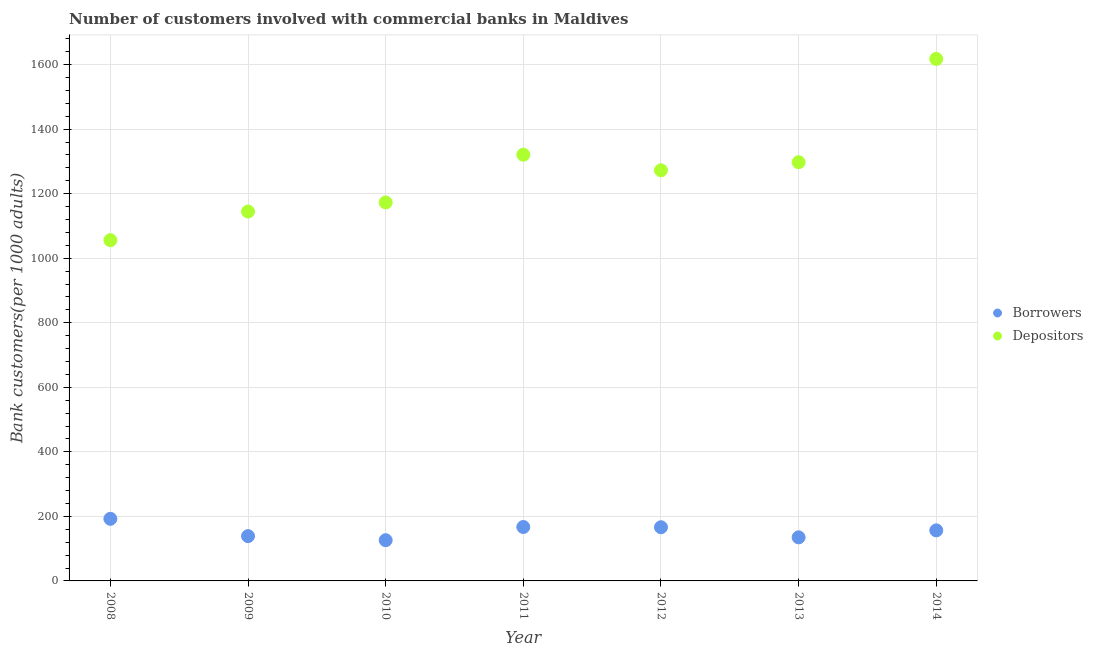How many different coloured dotlines are there?
Your answer should be very brief. 2. Is the number of dotlines equal to the number of legend labels?
Offer a terse response. Yes. What is the number of depositors in 2014?
Your answer should be compact. 1617.4. Across all years, what is the maximum number of depositors?
Give a very brief answer. 1617.4. Across all years, what is the minimum number of depositors?
Make the answer very short. 1055.84. In which year was the number of borrowers maximum?
Keep it short and to the point. 2008. In which year was the number of depositors minimum?
Offer a terse response. 2008. What is the total number of borrowers in the graph?
Offer a terse response. 1082.34. What is the difference between the number of borrowers in 2011 and that in 2013?
Ensure brevity in your answer.  32.03. What is the difference between the number of borrowers in 2011 and the number of depositors in 2012?
Give a very brief answer. -1105.32. What is the average number of borrowers per year?
Your answer should be very brief. 154.62. In the year 2014, what is the difference between the number of depositors and number of borrowers?
Provide a succinct answer. 1460.79. In how many years, is the number of depositors greater than 1400?
Make the answer very short. 1. What is the ratio of the number of depositors in 2012 to that in 2014?
Provide a short and direct response. 0.79. Is the number of depositors in 2011 less than that in 2014?
Make the answer very short. Yes. Is the difference between the number of depositors in 2009 and 2014 greater than the difference between the number of borrowers in 2009 and 2014?
Your answer should be compact. No. What is the difference between the highest and the second highest number of depositors?
Keep it short and to the point. 296.71. What is the difference between the highest and the lowest number of depositors?
Your answer should be compact. 561.56. In how many years, is the number of depositors greater than the average number of depositors taken over all years?
Offer a terse response. 4. How many dotlines are there?
Your response must be concise. 2. How many legend labels are there?
Give a very brief answer. 2. What is the title of the graph?
Your answer should be compact. Number of customers involved with commercial banks in Maldives. Does "IMF concessional" appear as one of the legend labels in the graph?
Make the answer very short. No. What is the label or title of the X-axis?
Offer a very short reply. Year. What is the label or title of the Y-axis?
Offer a very short reply. Bank customers(per 1000 adults). What is the Bank customers(per 1000 adults) of Borrowers in 2008?
Keep it short and to the point. 192.42. What is the Bank customers(per 1000 adults) of Depositors in 2008?
Provide a short and direct response. 1055.84. What is the Bank customers(per 1000 adults) in Borrowers in 2009?
Offer a very short reply. 138.77. What is the Bank customers(per 1000 adults) in Depositors in 2009?
Give a very brief answer. 1144.57. What is the Bank customers(per 1000 adults) of Borrowers in 2010?
Provide a succinct answer. 126.14. What is the Bank customers(per 1000 adults) in Depositors in 2010?
Offer a terse response. 1172.79. What is the Bank customers(per 1000 adults) in Borrowers in 2011?
Your answer should be very brief. 167.07. What is the Bank customers(per 1000 adults) in Depositors in 2011?
Offer a very short reply. 1320.69. What is the Bank customers(per 1000 adults) of Borrowers in 2012?
Offer a very short reply. 166.29. What is the Bank customers(per 1000 adults) of Depositors in 2012?
Offer a terse response. 1272.39. What is the Bank customers(per 1000 adults) in Borrowers in 2013?
Provide a short and direct response. 135.04. What is the Bank customers(per 1000 adults) of Depositors in 2013?
Keep it short and to the point. 1297.48. What is the Bank customers(per 1000 adults) in Borrowers in 2014?
Your response must be concise. 156.61. What is the Bank customers(per 1000 adults) of Depositors in 2014?
Make the answer very short. 1617.4. Across all years, what is the maximum Bank customers(per 1000 adults) of Borrowers?
Your response must be concise. 192.42. Across all years, what is the maximum Bank customers(per 1000 adults) of Depositors?
Give a very brief answer. 1617.4. Across all years, what is the minimum Bank customers(per 1000 adults) in Borrowers?
Ensure brevity in your answer.  126.14. Across all years, what is the minimum Bank customers(per 1000 adults) in Depositors?
Offer a terse response. 1055.84. What is the total Bank customers(per 1000 adults) of Borrowers in the graph?
Give a very brief answer. 1082.34. What is the total Bank customers(per 1000 adults) of Depositors in the graph?
Give a very brief answer. 8881.16. What is the difference between the Bank customers(per 1000 adults) of Borrowers in 2008 and that in 2009?
Offer a very short reply. 53.66. What is the difference between the Bank customers(per 1000 adults) in Depositors in 2008 and that in 2009?
Ensure brevity in your answer.  -88.73. What is the difference between the Bank customers(per 1000 adults) of Borrowers in 2008 and that in 2010?
Ensure brevity in your answer.  66.29. What is the difference between the Bank customers(per 1000 adults) in Depositors in 2008 and that in 2010?
Offer a terse response. -116.95. What is the difference between the Bank customers(per 1000 adults) in Borrowers in 2008 and that in 2011?
Your answer should be very brief. 25.36. What is the difference between the Bank customers(per 1000 adults) in Depositors in 2008 and that in 2011?
Ensure brevity in your answer.  -264.85. What is the difference between the Bank customers(per 1000 adults) in Borrowers in 2008 and that in 2012?
Offer a terse response. 26.13. What is the difference between the Bank customers(per 1000 adults) of Depositors in 2008 and that in 2012?
Give a very brief answer. -216.55. What is the difference between the Bank customers(per 1000 adults) of Borrowers in 2008 and that in 2013?
Your response must be concise. 57.38. What is the difference between the Bank customers(per 1000 adults) of Depositors in 2008 and that in 2013?
Ensure brevity in your answer.  -241.64. What is the difference between the Bank customers(per 1000 adults) in Borrowers in 2008 and that in 2014?
Your answer should be compact. 35.81. What is the difference between the Bank customers(per 1000 adults) of Depositors in 2008 and that in 2014?
Your response must be concise. -561.56. What is the difference between the Bank customers(per 1000 adults) of Borrowers in 2009 and that in 2010?
Ensure brevity in your answer.  12.63. What is the difference between the Bank customers(per 1000 adults) in Depositors in 2009 and that in 2010?
Your answer should be compact. -28.22. What is the difference between the Bank customers(per 1000 adults) in Borrowers in 2009 and that in 2011?
Provide a short and direct response. -28.3. What is the difference between the Bank customers(per 1000 adults) of Depositors in 2009 and that in 2011?
Offer a very short reply. -176.13. What is the difference between the Bank customers(per 1000 adults) in Borrowers in 2009 and that in 2012?
Provide a succinct answer. -27.52. What is the difference between the Bank customers(per 1000 adults) in Depositors in 2009 and that in 2012?
Give a very brief answer. -127.82. What is the difference between the Bank customers(per 1000 adults) in Borrowers in 2009 and that in 2013?
Provide a succinct answer. 3.73. What is the difference between the Bank customers(per 1000 adults) in Depositors in 2009 and that in 2013?
Your answer should be compact. -152.92. What is the difference between the Bank customers(per 1000 adults) of Borrowers in 2009 and that in 2014?
Your answer should be very brief. -17.85. What is the difference between the Bank customers(per 1000 adults) in Depositors in 2009 and that in 2014?
Provide a short and direct response. -472.84. What is the difference between the Bank customers(per 1000 adults) in Borrowers in 2010 and that in 2011?
Give a very brief answer. -40.93. What is the difference between the Bank customers(per 1000 adults) of Depositors in 2010 and that in 2011?
Your answer should be very brief. -147.91. What is the difference between the Bank customers(per 1000 adults) of Borrowers in 2010 and that in 2012?
Provide a succinct answer. -40.15. What is the difference between the Bank customers(per 1000 adults) of Depositors in 2010 and that in 2012?
Ensure brevity in your answer.  -99.6. What is the difference between the Bank customers(per 1000 adults) in Borrowers in 2010 and that in 2013?
Your answer should be compact. -8.9. What is the difference between the Bank customers(per 1000 adults) in Depositors in 2010 and that in 2013?
Provide a succinct answer. -124.7. What is the difference between the Bank customers(per 1000 adults) in Borrowers in 2010 and that in 2014?
Keep it short and to the point. -30.48. What is the difference between the Bank customers(per 1000 adults) of Depositors in 2010 and that in 2014?
Provide a short and direct response. -444.62. What is the difference between the Bank customers(per 1000 adults) in Borrowers in 2011 and that in 2012?
Your answer should be very brief. 0.78. What is the difference between the Bank customers(per 1000 adults) in Depositors in 2011 and that in 2012?
Provide a short and direct response. 48.3. What is the difference between the Bank customers(per 1000 adults) in Borrowers in 2011 and that in 2013?
Offer a terse response. 32.03. What is the difference between the Bank customers(per 1000 adults) in Depositors in 2011 and that in 2013?
Offer a terse response. 23.21. What is the difference between the Bank customers(per 1000 adults) of Borrowers in 2011 and that in 2014?
Make the answer very short. 10.45. What is the difference between the Bank customers(per 1000 adults) of Depositors in 2011 and that in 2014?
Your answer should be compact. -296.71. What is the difference between the Bank customers(per 1000 adults) in Borrowers in 2012 and that in 2013?
Provide a short and direct response. 31.25. What is the difference between the Bank customers(per 1000 adults) of Depositors in 2012 and that in 2013?
Ensure brevity in your answer.  -25.1. What is the difference between the Bank customers(per 1000 adults) of Borrowers in 2012 and that in 2014?
Your answer should be compact. 9.68. What is the difference between the Bank customers(per 1000 adults) of Depositors in 2012 and that in 2014?
Your answer should be very brief. -345.02. What is the difference between the Bank customers(per 1000 adults) in Borrowers in 2013 and that in 2014?
Your answer should be compact. -21.58. What is the difference between the Bank customers(per 1000 adults) of Depositors in 2013 and that in 2014?
Your answer should be compact. -319.92. What is the difference between the Bank customers(per 1000 adults) in Borrowers in 2008 and the Bank customers(per 1000 adults) in Depositors in 2009?
Keep it short and to the point. -952.14. What is the difference between the Bank customers(per 1000 adults) of Borrowers in 2008 and the Bank customers(per 1000 adults) of Depositors in 2010?
Your response must be concise. -980.36. What is the difference between the Bank customers(per 1000 adults) in Borrowers in 2008 and the Bank customers(per 1000 adults) in Depositors in 2011?
Your answer should be very brief. -1128.27. What is the difference between the Bank customers(per 1000 adults) of Borrowers in 2008 and the Bank customers(per 1000 adults) of Depositors in 2012?
Offer a very short reply. -1079.96. What is the difference between the Bank customers(per 1000 adults) of Borrowers in 2008 and the Bank customers(per 1000 adults) of Depositors in 2013?
Make the answer very short. -1105.06. What is the difference between the Bank customers(per 1000 adults) in Borrowers in 2008 and the Bank customers(per 1000 adults) in Depositors in 2014?
Keep it short and to the point. -1424.98. What is the difference between the Bank customers(per 1000 adults) in Borrowers in 2009 and the Bank customers(per 1000 adults) in Depositors in 2010?
Your answer should be compact. -1034.02. What is the difference between the Bank customers(per 1000 adults) of Borrowers in 2009 and the Bank customers(per 1000 adults) of Depositors in 2011?
Your response must be concise. -1181.92. What is the difference between the Bank customers(per 1000 adults) in Borrowers in 2009 and the Bank customers(per 1000 adults) in Depositors in 2012?
Provide a short and direct response. -1133.62. What is the difference between the Bank customers(per 1000 adults) in Borrowers in 2009 and the Bank customers(per 1000 adults) in Depositors in 2013?
Offer a very short reply. -1158.72. What is the difference between the Bank customers(per 1000 adults) of Borrowers in 2009 and the Bank customers(per 1000 adults) of Depositors in 2014?
Your answer should be very brief. -1478.64. What is the difference between the Bank customers(per 1000 adults) in Borrowers in 2010 and the Bank customers(per 1000 adults) in Depositors in 2011?
Your answer should be compact. -1194.55. What is the difference between the Bank customers(per 1000 adults) of Borrowers in 2010 and the Bank customers(per 1000 adults) of Depositors in 2012?
Provide a short and direct response. -1146.25. What is the difference between the Bank customers(per 1000 adults) of Borrowers in 2010 and the Bank customers(per 1000 adults) of Depositors in 2013?
Offer a very short reply. -1171.35. What is the difference between the Bank customers(per 1000 adults) in Borrowers in 2010 and the Bank customers(per 1000 adults) in Depositors in 2014?
Your answer should be compact. -1491.27. What is the difference between the Bank customers(per 1000 adults) in Borrowers in 2011 and the Bank customers(per 1000 adults) in Depositors in 2012?
Give a very brief answer. -1105.32. What is the difference between the Bank customers(per 1000 adults) of Borrowers in 2011 and the Bank customers(per 1000 adults) of Depositors in 2013?
Give a very brief answer. -1130.42. What is the difference between the Bank customers(per 1000 adults) of Borrowers in 2011 and the Bank customers(per 1000 adults) of Depositors in 2014?
Provide a short and direct response. -1450.34. What is the difference between the Bank customers(per 1000 adults) of Borrowers in 2012 and the Bank customers(per 1000 adults) of Depositors in 2013?
Your answer should be compact. -1131.19. What is the difference between the Bank customers(per 1000 adults) in Borrowers in 2012 and the Bank customers(per 1000 adults) in Depositors in 2014?
Ensure brevity in your answer.  -1451.11. What is the difference between the Bank customers(per 1000 adults) in Borrowers in 2013 and the Bank customers(per 1000 adults) in Depositors in 2014?
Give a very brief answer. -1482.37. What is the average Bank customers(per 1000 adults) of Borrowers per year?
Provide a short and direct response. 154.62. What is the average Bank customers(per 1000 adults) in Depositors per year?
Your answer should be very brief. 1268.74. In the year 2008, what is the difference between the Bank customers(per 1000 adults) in Borrowers and Bank customers(per 1000 adults) in Depositors?
Offer a very short reply. -863.42. In the year 2009, what is the difference between the Bank customers(per 1000 adults) of Borrowers and Bank customers(per 1000 adults) of Depositors?
Make the answer very short. -1005.8. In the year 2010, what is the difference between the Bank customers(per 1000 adults) of Borrowers and Bank customers(per 1000 adults) of Depositors?
Your answer should be very brief. -1046.65. In the year 2011, what is the difference between the Bank customers(per 1000 adults) of Borrowers and Bank customers(per 1000 adults) of Depositors?
Make the answer very short. -1153.63. In the year 2012, what is the difference between the Bank customers(per 1000 adults) of Borrowers and Bank customers(per 1000 adults) of Depositors?
Your answer should be very brief. -1106.1. In the year 2013, what is the difference between the Bank customers(per 1000 adults) in Borrowers and Bank customers(per 1000 adults) in Depositors?
Offer a terse response. -1162.45. In the year 2014, what is the difference between the Bank customers(per 1000 adults) in Borrowers and Bank customers(per 1000 adults) in Depositors?
Your answer should be very brief. -1460.79. What is the ratio of the Bank customers(per 1000 adults) of Borrowers in 2008 to that in 2009?
Keep it short and to the point. 1.39. What is the ratio of the Bank customers(per 1000 adults) in Depositors in 2008 to that in 2009?
Make the answer very short. 0.92. What is the ratio of the Bank customers(per 1000 adults) of Borrowers in 2008 to that in 2010?
Provide a short and direct response. 1.53. What is the ratio of the Bank customers(per 1000 adults) in Depositors in 2008 to that in 2010?
Give a very brief answer. 0.9. What is the ratio of the Bank customers(per 1000 adults) of Borrowers in 2008 to that in 2011?
Your answer should be compact. 1.15. What is the ratio of the Bank customers(per 1000 adults) of Depositors in 2008 to that in 2011?
Provide a succinct answer. 0.8. What is the ratio of the Bank customers(per 1000 adults) in Borrowers in 2008 to that in 2012?
Offer a very short reply. 1.16. What is the ratio of the Bank customers(per 1000 adults) of Depositors in 2008 to that in 2012?
Offer a very short reply. 0.83. What is the ratio of the Bank customers(per 1000 adults) in Borrowers in 2008 to that in 2013?
Keep it short and to the point. 1.43. What is the ratio of the Bank customers(per 1000 adults) of Depositors in 2008 to that in 2013?
Your response must be concise. 0.81. What is the ratio of the Bank customers(per 1000 adults) of Borrowers in 2008 to that in 2014?
Provide a short and direct response. 1.23. What is the ratio of the Bank customers(per 1000 adults) in Depositors in 2008 to that in 2014?
Offer a terse response. 0.65. What is the ratio of the Bank customers(per 1000 adults) of Borrowers in 2009 to that in 2010?
Give a very brief answer. 1.1. What is the ratio of the Bank customers(per 1000 adults) of Depositors in 2009 to that in 2010?
Make the answer very short. 0.98. What is the ratio of the Bank customers(per 1000 adults) in Borrowers in 2009 to that in 2011?
Provide a short and direct response. 0.83. What is the ratio of the Bank customers(per 1000 adults) of Depositors in 2009 to that in 2011?
Keep it short and to the point. 0.87. What is the ratio of the Bank customers(per 1000 adults) in Borrowers in 2009 to that in 2012?
Your answer should be very brief. 0.83. What is the ratio of the Bank customers(per 1000 adults) in Depositors in 2009 to that in 2012?
Your answer should be very brief. 0.9. What is the ratio of the Bank customers(per 1000 adults) in Borrowers in 2009 to that in 2013?
Ensure brevity in your answer.  1.03. What is the ratio of the Bank customers(per 1000 adults) in Depositors in 2009 to that in 2013?
Make the answer very short. 0.88. What is the ratio of the Bank customers(per 1000 adults) of Borrowers in 2009 to that in 2014?
Your response must be concise. 0.89. What is the ratio of the Bank customers(per 1000 adults) of Depositors in 2009 to that in 2014?
Give a very brief answer. 0.71. What is the ratio of the Bank customers(per 1000 adults) of Borrowers in 2010 to that in 2011?
Your response must be concise. 0.76. What is the ratio of the Bank customers(per 1000 adults) of Depositors in 2010 to that in 2011?
Your response must be concise. 0.89. What is the ratio of the Bank customers(per 1000 adults) of Borrowers in 2010 to that in 2012?
Give a very brief answer. 0.76. What is the ratio of the Bank customers(per 1000 adults) in Depositors in 2010 to that in 2012?
Make the answer very short. 0.92. What is the ratio of the Bank customers(per 1000 adults) of Borrowers in 2010 to that in 2013?
Provide a short and direct response. 0.93. What is the ratio of the Bank customers(per 1000 adults) of Depositors in 2010 to that in 2013?
Offer a very short reply. 0.9. What is the ratio of the Bank customers(per 1000 adults) in Borrowers in 2010 to that in 2014?
Keep it short and to the point. 0.81. What is the ratio of the Bank customers(per 1000 adults) of Depositors in 2010 to that in 2014?
Make the answer very short. 0.73. What is the ratio of the Bank customers(per 1000 adults) in Borrowers in 2011 to that in 2012?
Keep it short and to the point. 1. What is the ratio of the Bank customers(per 1000 adults) in Depositors in 2011 to that in 2012?
Provide a succinct answer. 1.04. What is the ratio of the Bank customers(per 1000 adults) of Borrowers in 2011 to that in 2013?
Give a very brief answer. 1.24. What is the ratio of the Bank customers(per 1000 adults) in Depositors in 2011 to that in 2013?
Offer a very short reply. 1.02. What is the ratio of the Bank customers(per 1000 adults) of Borrowers in 2011 to that in 2014?
Provide a short and direct response. 1.07. What is the ratio of the Bank customers(per 1000 adults) of Depositors in 2011 to that in 2014?
Give a very brief answer. 0.82. What is the ratio of the Bank customers(per 1000 adults) in Borrowers in 2012 to that in 2013?
Your answer should be very brief. 1.23. What is the ratio of the Bank customers(per 1000 adults) in Depositors in 2012 to that in 2013?
Your answer should be compact. 0.98. What is the ratio of the Bank customers(per 1000 adults) of Borrowers in 2012 to that in 2014?
Offer a very short reply. 1.06. What is the ratio of the Bank customers(per 1000 adults) of Depositors in 2012 to that in 2014?
Your answer should be very brief. 0.79. What is the ratio of the Bank customers(per 1000 adults) of Borrowers in 2013 to that in 2014?
Your answer should be very brief. 0.86. What is the ratio of the Bank customers(per 1000 adults) in Depositors in 2013 to that in 2014?
Your answer should be very brief. 0.8. What is the difference between the highest and the second highest Bank customers(per 1000 adults) of Borrowers?
Ensure brevity in your answer.  25.36. What is the difference between the highest and the second highest Bank customers(per 1000 adults) of Depositors?
Your response must be concise. 296.71. What is the difference between the highest and the lowest Bank customers(per 1000 adults) in Borrowers?
Give a very brief answer. 66.29. What is the difference between the highest and the lowest Bank customers(per 1000 adults) of Depositors?
Ensure brevity in your answer.  561.56. 